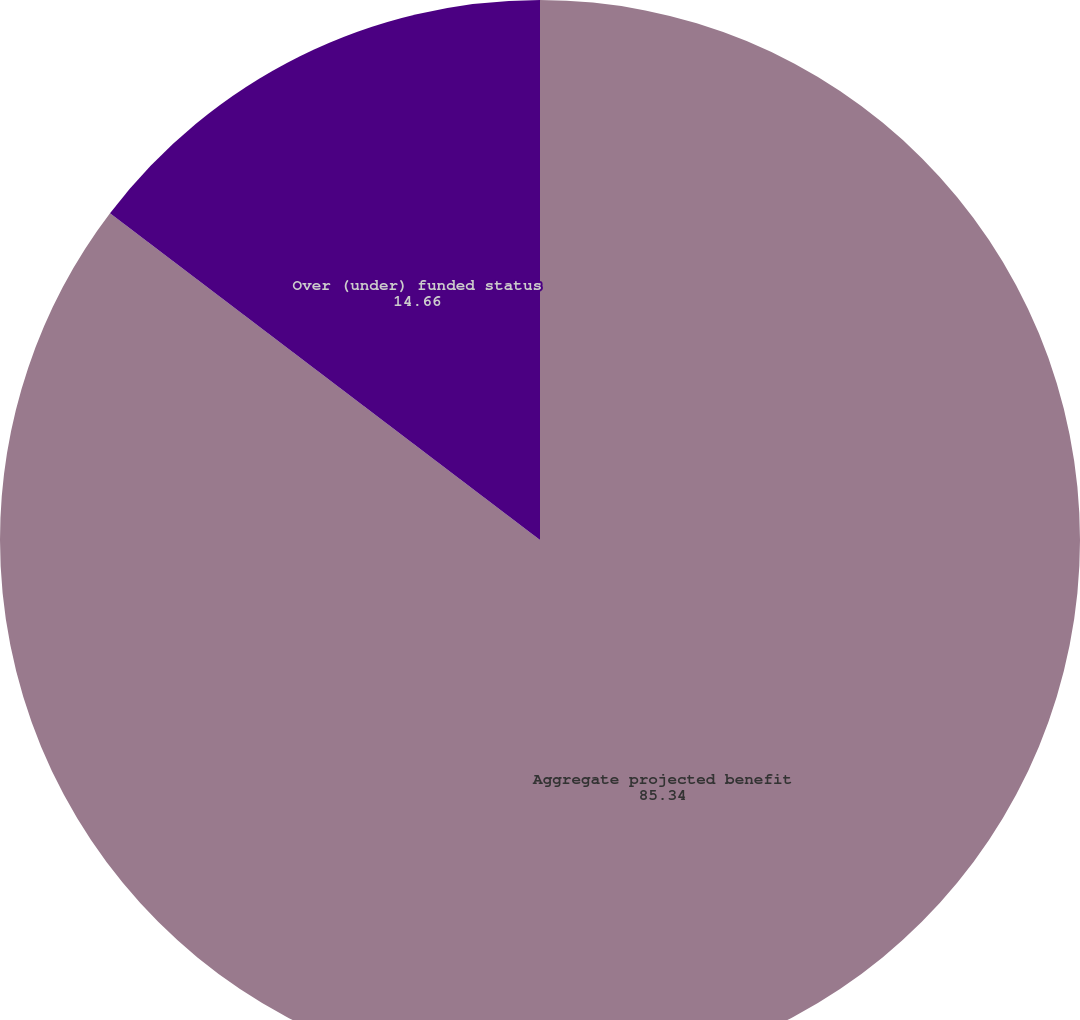<chart> <loc_0><loc_0><loc_500><loc_500><pie_chart><fcel>Aggregate projected benefit<fcel>Over (under) funded status<nl><fcel>85.34%<fcel>14.66%<nl></chart> 